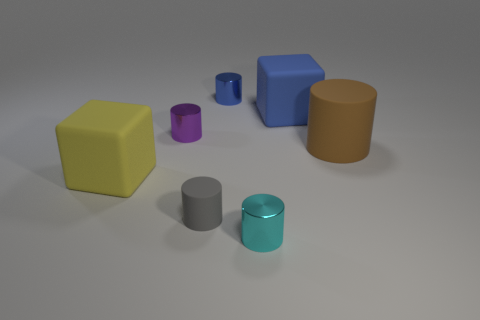Add 2 cyan metal cylinders. How many objects exist? 9 Subtract 2 cylinders. How many cylinders are left? 3 Subtract all gray rubber cylinders. How many cylinders are left? 4 Subtract all cyan cylinders. How many cylinders are left? 4 Subtract all cylinders. How many objects are left? 2 Subtract all green cylinders. Subtract all brown balls. How many cylinders are left? 5 Add 7 big green balls. How many big green balls exist? 7 Subtract 0 yellow spheres. How many objects are left? 7 Subtract all big blue things. Subtract all tiny cyan metal objects. How many objects are left? 5 Add 5 blocks. How many blocks are left? 7 